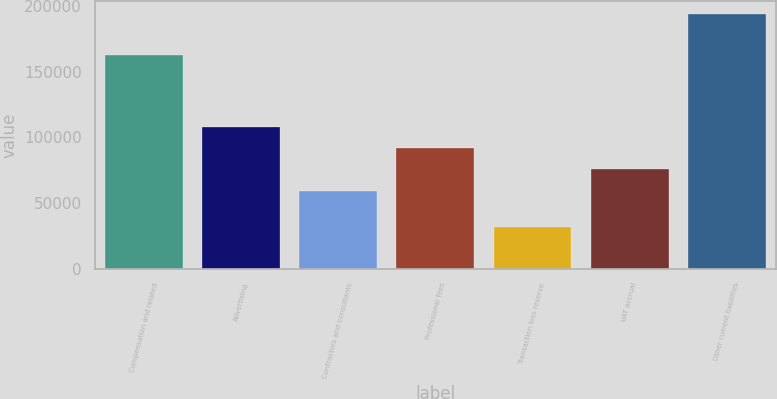<chart> <loc_0><loc_0><loc_500><loc_500><bar_chart><fcel>Compensation and related<fcel>Advertising<fcel>Contractors and consultants<fcel>Professional fees<fcel>Transaction loss reserve<fcel>VAT accrual<fcel>Other current liabilities<nl><fcel>162889<fcel>107979<fcel>59371<fcel>91776.6<fcel>32140<fcel>75573.8<fcel>194168<nl></chart> 